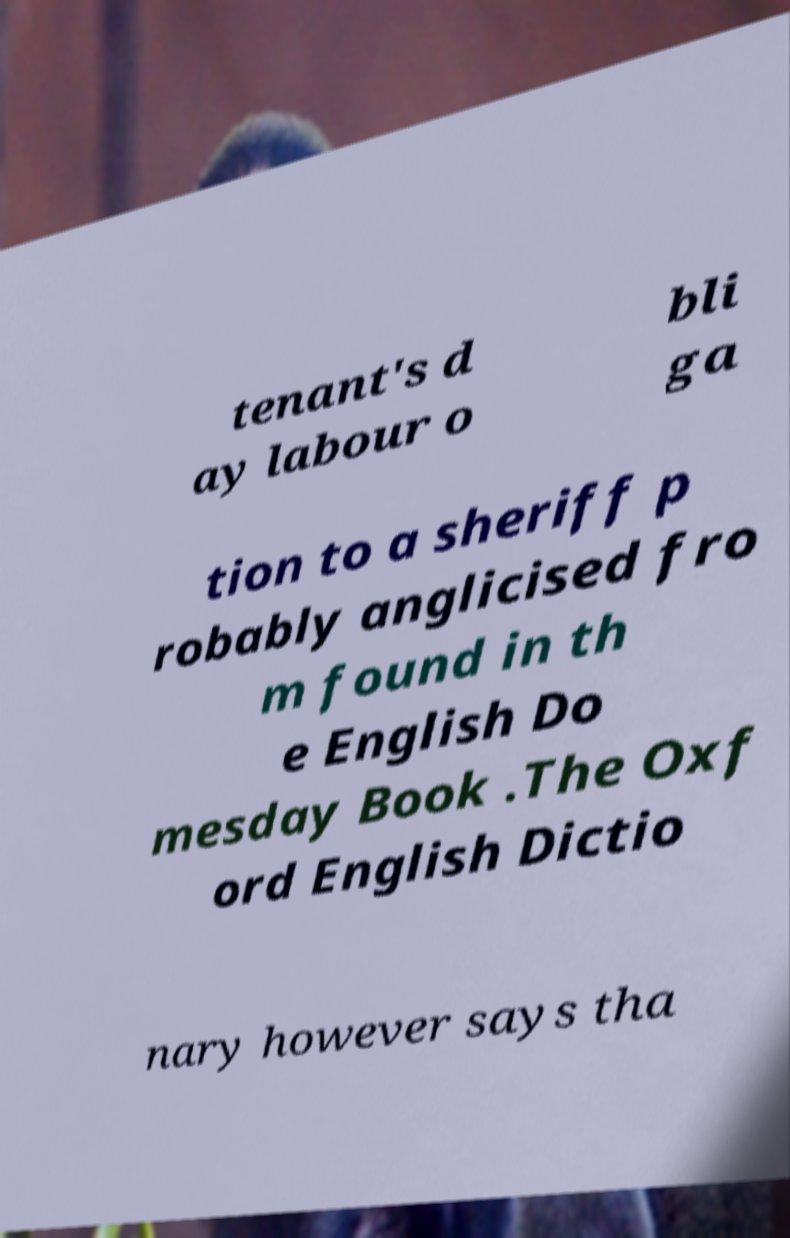Could you extract and type out the text from this image? tenant's d ay labour o bli ga tion to a sheriff p robably anglicised fro m found in th e English Do mesday Book .The Oxf ord English Dictio nary however says tha 